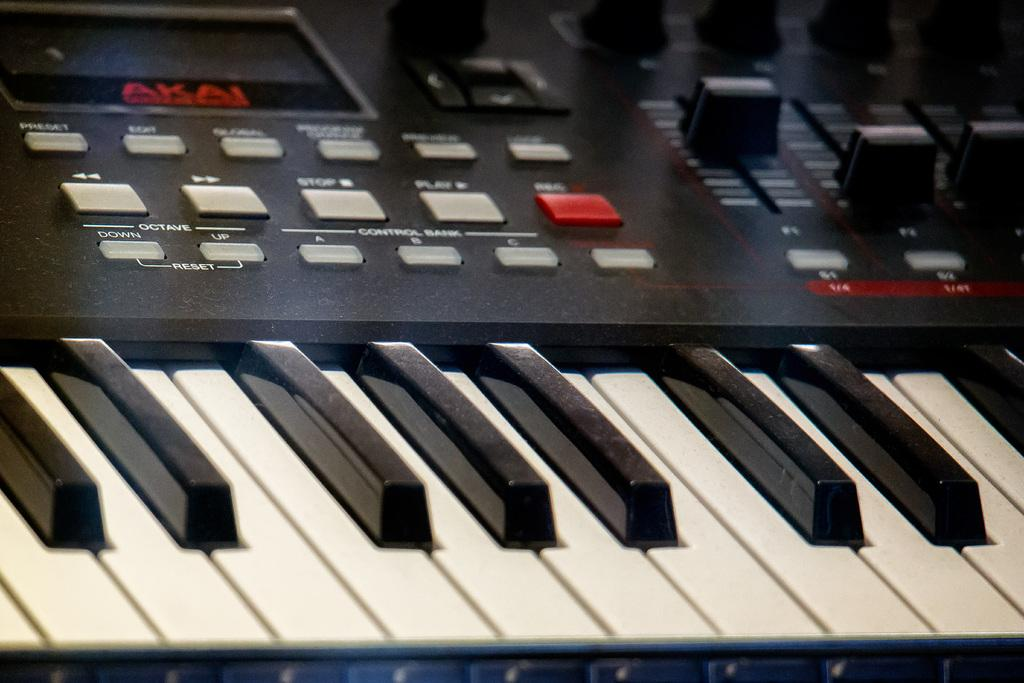<image>
Write a terse but informative summary of the picture. An Akai brand keyboard with a switch board attachment 